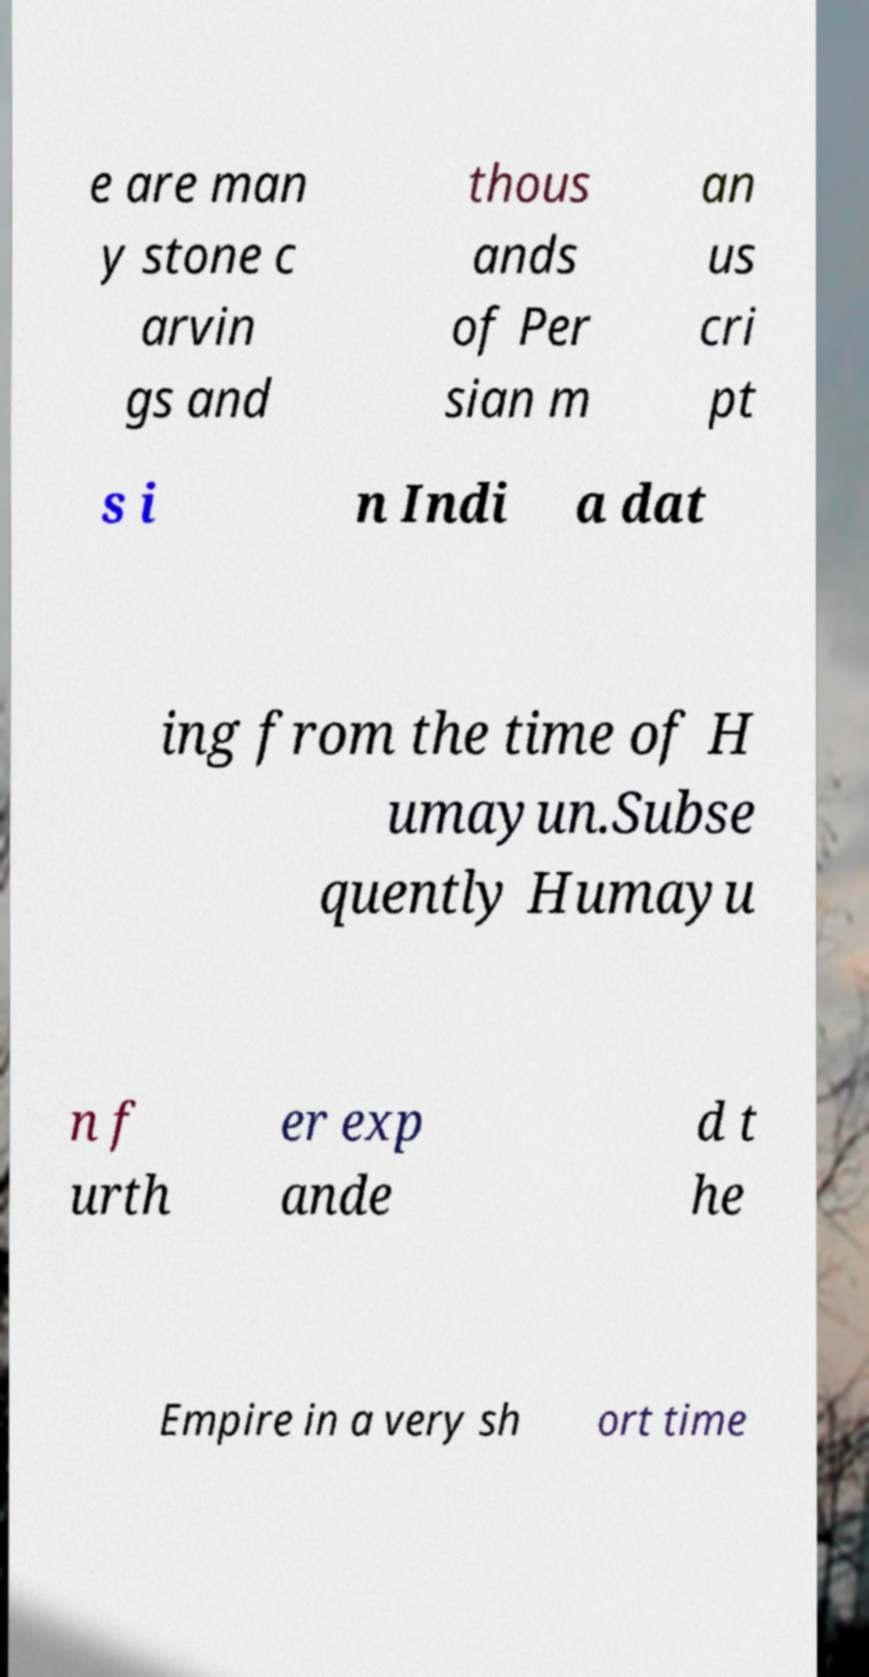For documentation purposes, I need the text within this image transcribed. Could you provide that? e are man y stone c arvin gs and thous ands of Per sian m an us cri pt s i n Indi a dat ing from the time of H umayun.Subse quently Humayu n f urth er exp ande d t he Empire in a very sh ort time 